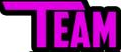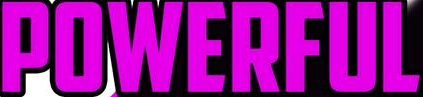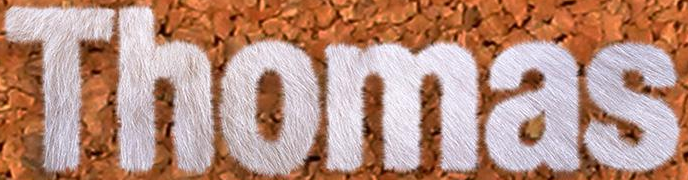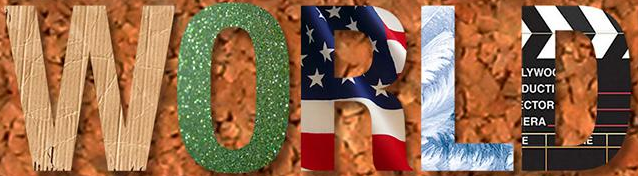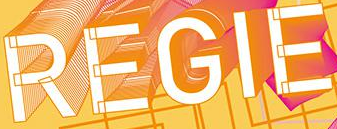Read the text content from these images in order, separated by a semicolon. TEAM; POWERFUL; Thomas; WORLD; REGIE 